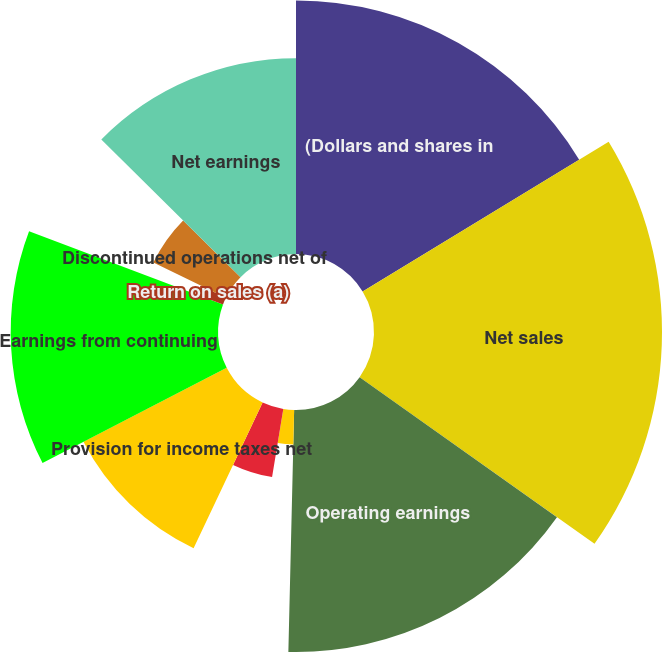Convert chart. <chart><loc_0><loc_0><loc_500><loc_500><pie_chart><fcel>(Dollars and shares in<fcel>Net sales<fcel>Operating earnings<fcel>Operating margin<fcel>Interest net<fcel>Provision for income taxes net<fcel>Earnings from continuing<fcel>Return on sales (a)<fcel>Discontinued operations net of<fcel>Net earnings<nl><fcel>16.3%<fcel>18.52%<fcel>15.56%<fcel>2.22%<fcel>4.44%<fcel>10.37%<fcel>13.33%<fcel>1.48%<fcel>5.19%<fcel>12.59%<nl></chart> 